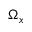Convert formula to latex. <formula><loc_0><loc_0><loc_500><loc_500>\Omega _ { x }</formula> 